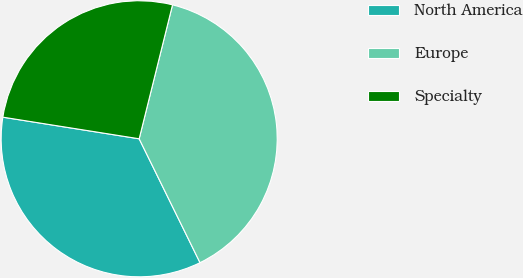Convert chart. <chart><loc_0><loc_0><loc_500><loc_500><pie_chart><fcel>North America<fcel>Europe<fcel>Specialty<nl><fcel>34.77%<fcel>38.85%<fcel>26.38%<nl></chart> 